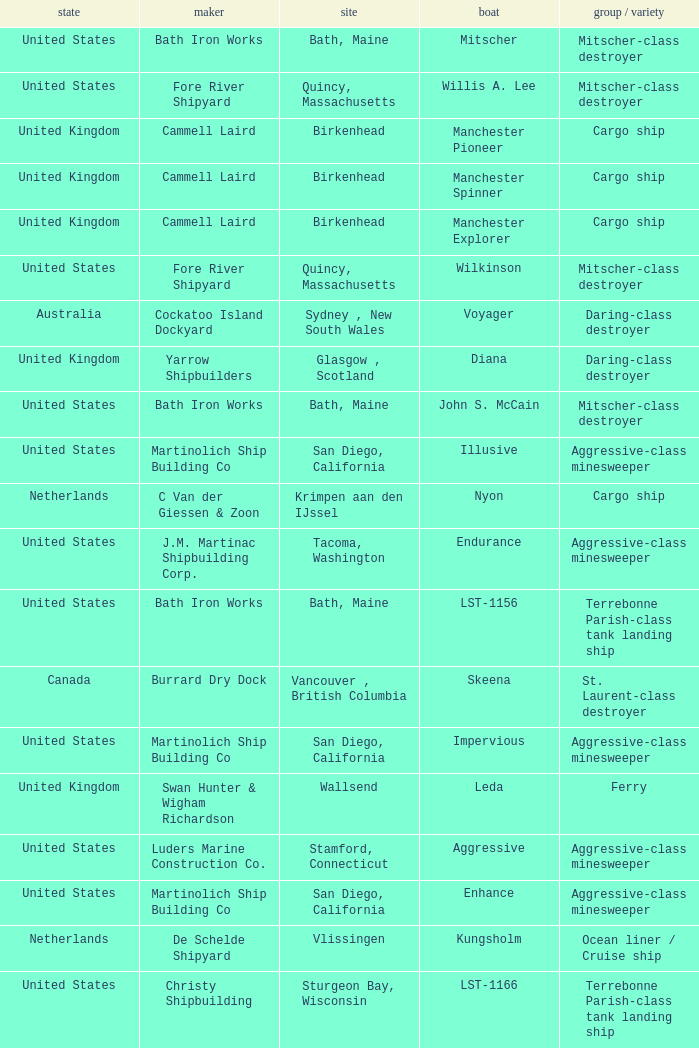What Country is the John S. McCain Ship from? United States. 